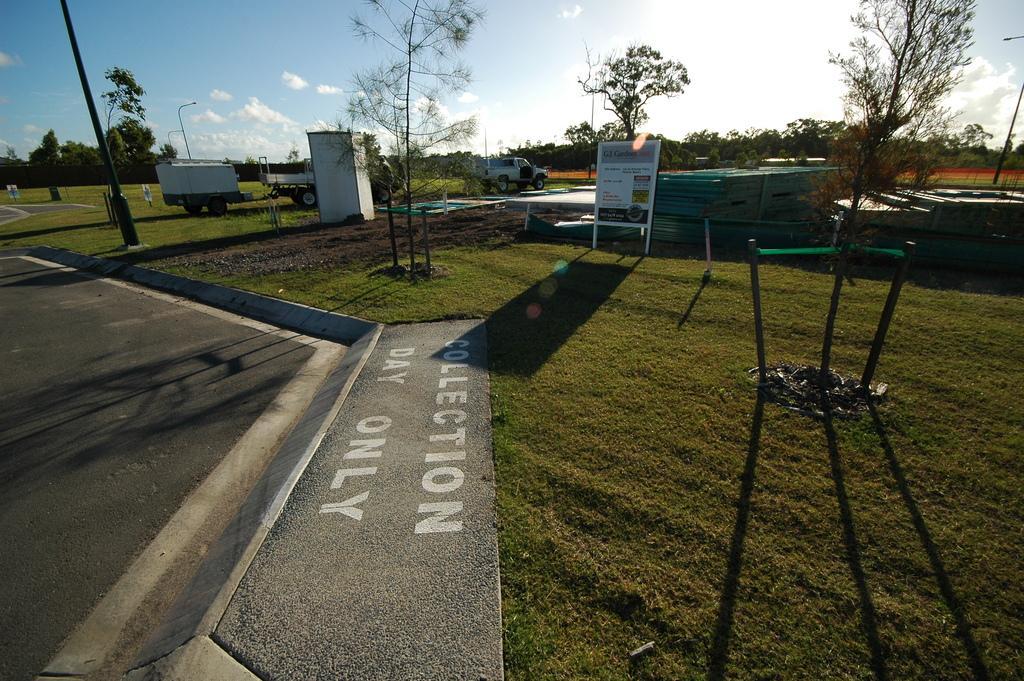Can you describe this image briefly? In the image there is a road on the left side and grassland on the right side and with few trees and trucks on it in the background and above its sky with clouds. 